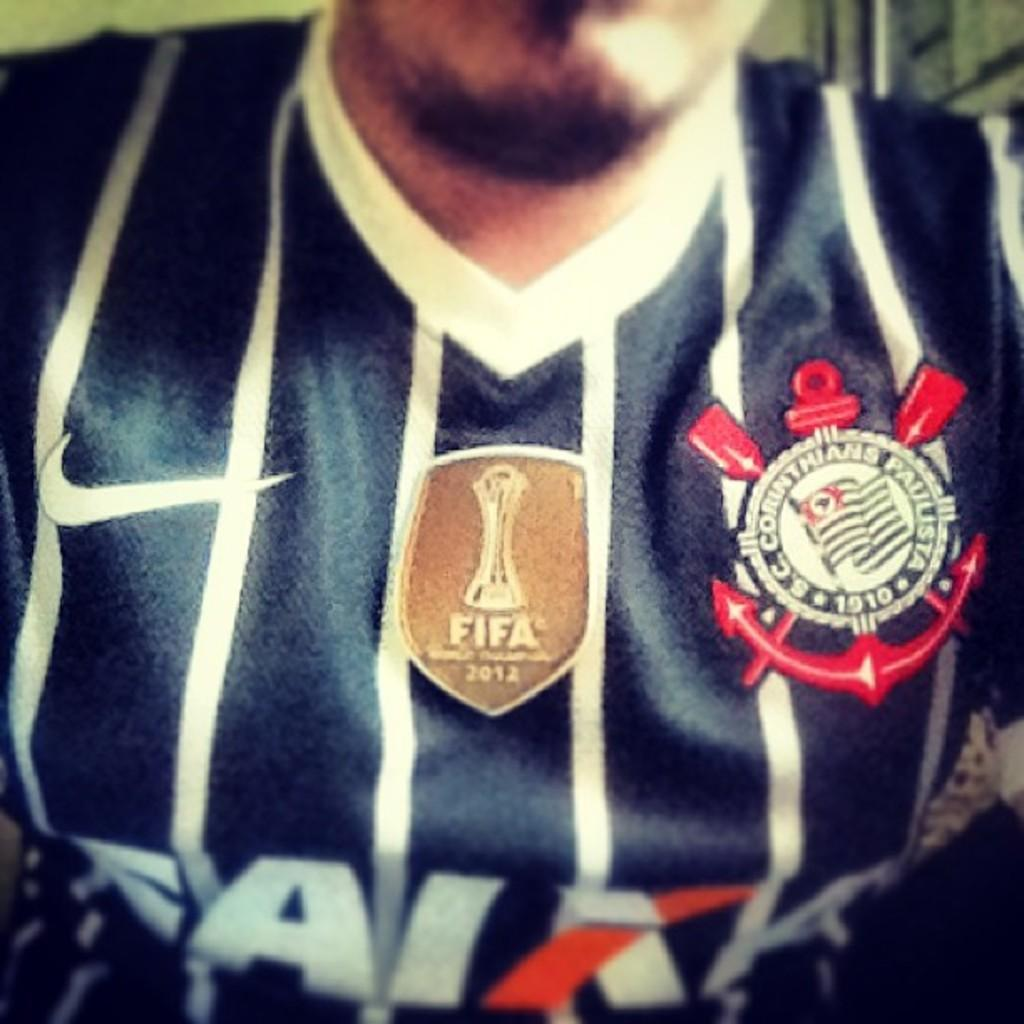<image>
Give a short and clear explanation of the subsequent image. A closeup of a man wearing a blue FIFA 2012 soccer jersey. 